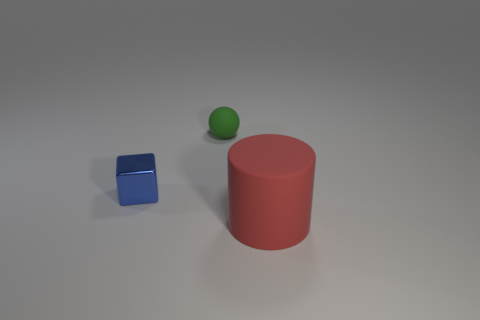Add 2 big red cylinders. How many objects exist? 5 Subtract all cylinders. How many objects are left? 2 Subtract all brown blocks. How many gray cylinders are left? 0 Subtract all large red things. Subtract all yellow matte objects. How many objects are left? 2 Add 1 green matte spheres. How many green matte spheres are left? 2 Add 3 cyan metal spheres. How many cyan metal spheres exist? 3 Subtract 0 blue balls. How many objects are left? 3 Subtract all gray blocks. Subtract all gray cylinders. How many blocks are left? 1 